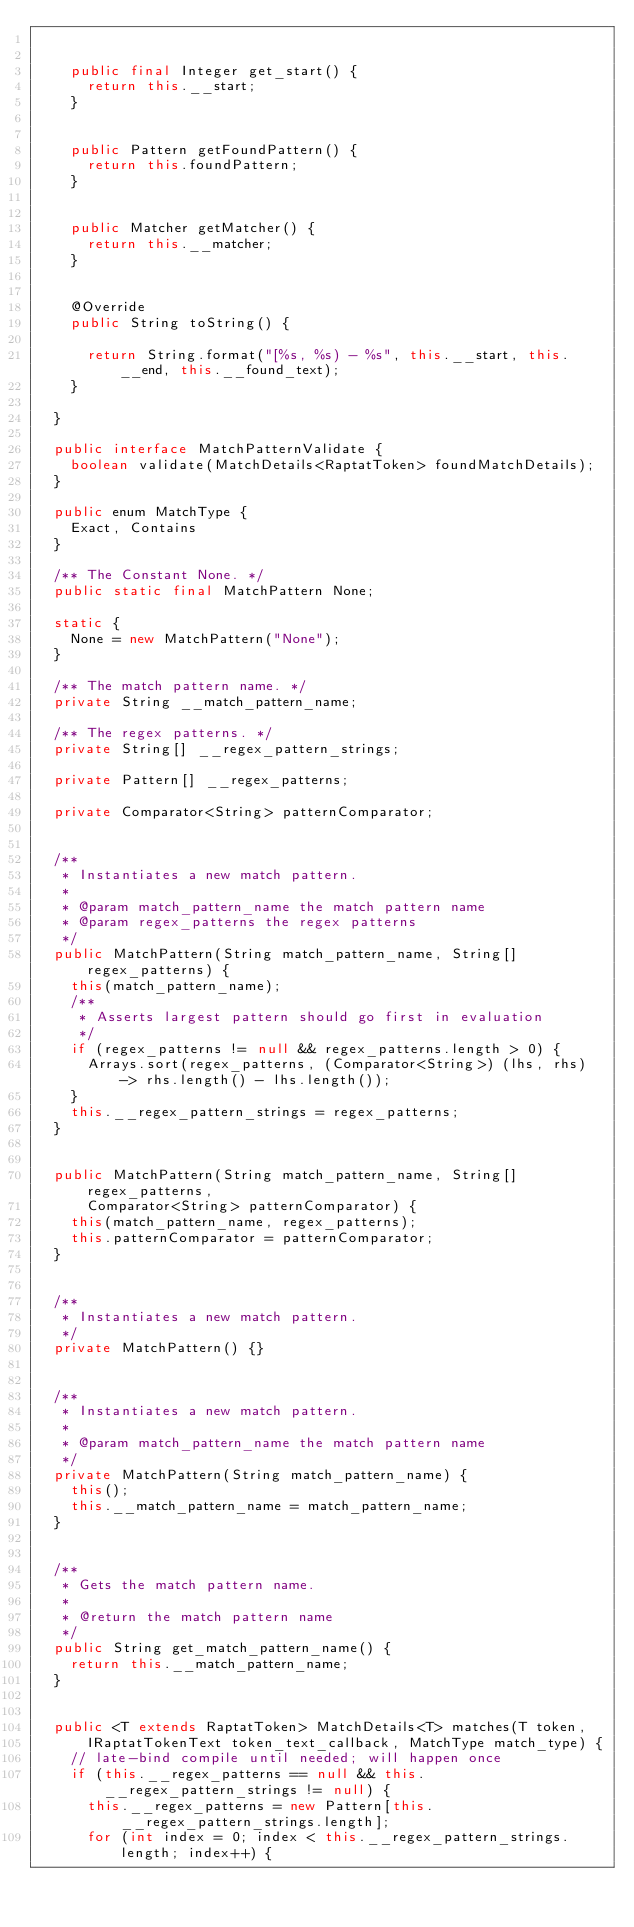Convert code to text. <code><loc_0><loc_0><loc_500><loc_500><_Java_>

    public final Integer get_start() {
      return this.__start;
    }


    public Pattern getFoundPattern() {
      return this.foundPattern;
    }


    public Matcher getMatcher() {
      return this.__matcher;
    }


    @Override
    public String toString() {

      return String.format("[%s, %s) - %s", this.__start, this.__end, this.__found_text);
    }

  }

  public interface MatchPatternValidate {
    boolean validate(MatchDetails<RaptatToken> foundMatchDetails);
  }

  public enum MatchType {
    Exact, Contains
  }

  /** The Constant None. */
  public static final MatchPattern None;

  static {
    None = new MatchPattern("None");
  }

  /** The match pattern name. */
  private String __match_pattern_name;

  /** The regex patterns. */
  private String[] __regex_pattern_strings;

  private Pattern[] __regex_patterns;

  private Comparator<String> patternComparator;


  /**
   * Instantiates a new match pattern.
   *
   * @param match_pattern_name the match pattern name
   * @param regex_patterns the regex patterns
   */
  public MatchPattern(String match_pattern_name, String[] regex_patterns) {
    this(match_pattern_name);
    /**
     * Asserts largest pattern should go first in evaluation
     */
    if (regex_patterns != null && regex_patterns.length > 0) {
      Arrays.sort(regex_patterns, (Comparator<String>) (lhs, rhs) -> rhs.length() - lhs.length());
    }
    this.__regex_pattern_strings = regex_patterns;
  }


  public MatchPattern(String match_pattern_name, String[] regex_patterns,
      Comparator<String> patternComparator) {
    this(match_pattern_name, regex_patterns);
    this.patternComparator = patternComparator;
  }


  /**
   * Instantiates a new match pattern.
   */
  private MatchPattern() {}


  /**
   * Instantiates a new match pattern.
   *
   * @param match_pattern_name the match pattern name
   */
  private MatchPattern(String match_pattern_name) {
    this();
    this.__match_pattern_name = match_pattern_name;
  }


  /**
   * Gets the match pattern name.
   *
   * @return the match pattern name
   */
  public String get_match_pattern_name() {
    return this.__match_pattern_name;
  }


  public <T extends RaptatToken> MatchDetails<T> matches(T token,
      IRaptatTokenText token_text_callback, MatchType match_type) {
    // late-bind compile until needed; will happen once
    if (this.__regex_patterns == null && this.__regex_pattern_strings != null) {
      this.__regex_patterns = new Pattern[this.__regex_pattern_strings.length];
      for (int index = 0; index < this.__regex_pattern_strings.length; index++) {</code> 